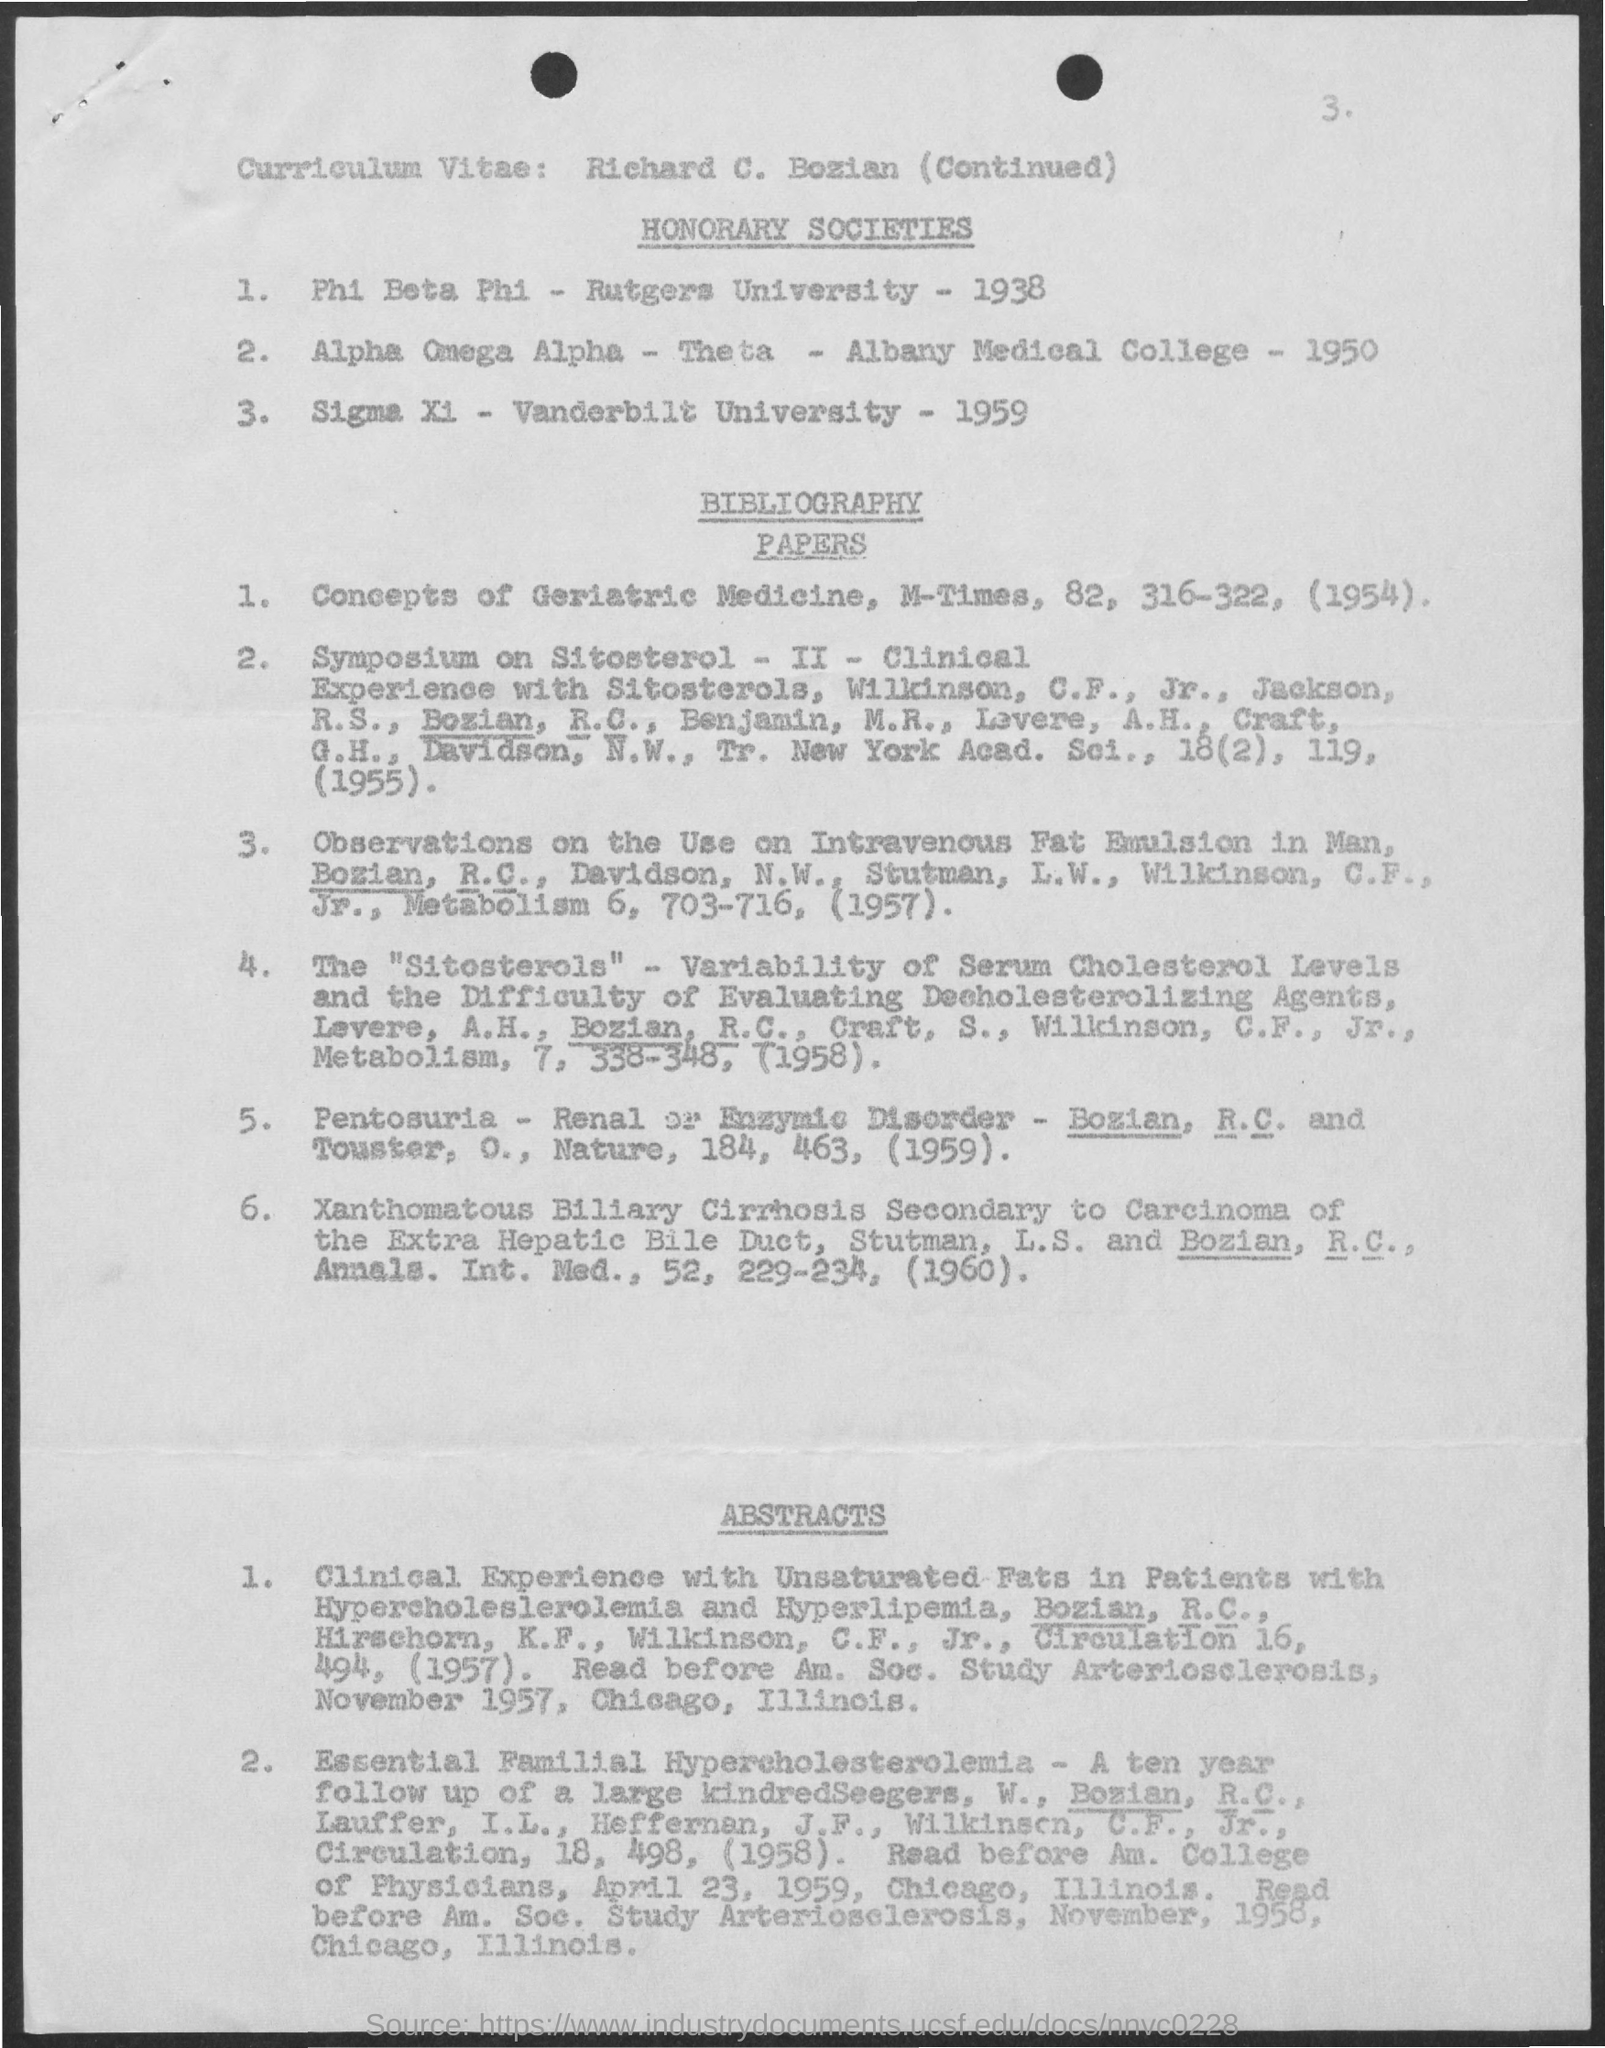Whose curriculum vitae is this?
Your answer should be very brief. Richard C. Bozian. 